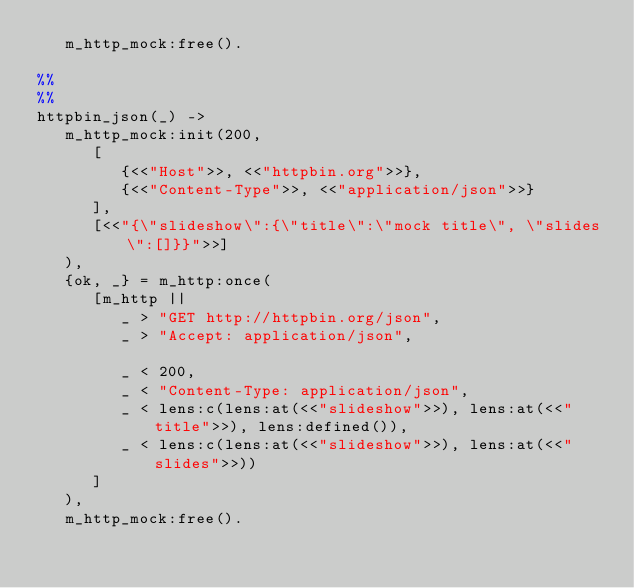<code> <loc_0><loc_0><loc_500><loc_500><_Erlang_>   m_http_mock:free().

%%
%%
httpbin_json(_) ->
   m_http_mock:init(200, 
      [
         {<<"Host">>, <<"httpbin.org">>},
         {<<"Content-Type">>, <<"application/json">>}
      ],
      [<<"{\"slideshow\":{\"title\":\"mock title\", \"slides\":[]}}">>]
   ),
   {ok, _} = m_http:once(
      [m_http ||
         _ > "GET http://httpbin.org/json",
         _ > "Accept: application/json",

         _ < 200,
         _ < "Content-Type: application/json",
         _ < lens:c(lens:at(<<"slideshow">>), lens:at(<<"title">>), lens:defined()),
         _ < lens:c(lens:at(<<"slideshow">>), lens:at(<<"slides">>))
      ]
   ),
   m_http_mock:free().
</code> 